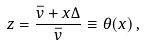<formula> <loc_0><loc_0><loc_500><loc_500>z = \frac { \bar { v } + x \Delta } { \bar { v } } \equiv \theta ( x ) \, ,</formula> 